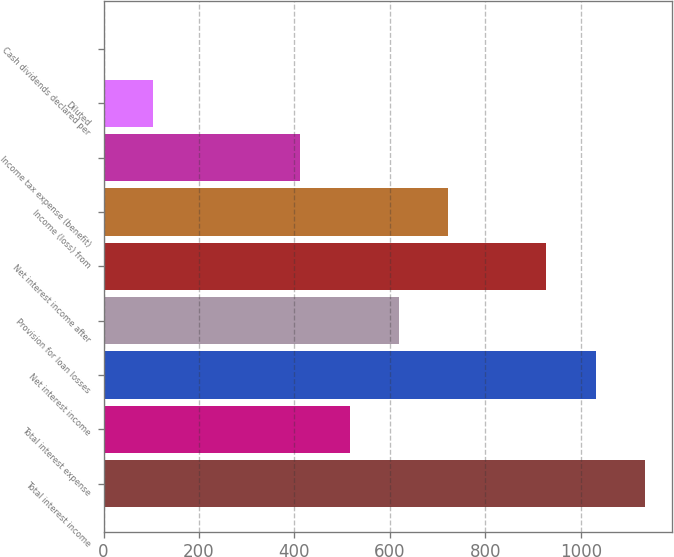<chart> <loc_0><loc_0><loc_500><loc_500><bar_chart><fcel>Total interest income<fcel>Total interest expense<fcel>Net interest income<fcel>Provision for loan losses<fcel>Net interest income after<fcel>Income (loss) from<fcel>Income tax expense (benefit)<fcel>Diluted<fcel>Cash dividends declared per<nl><fcel>1134.11<fcel>515.51<fcel>1031.01<fcel>618.61<fcel>927.91<fcel>721.71<fcel>412.41<fcel>103.11<fcel>0.01<nl></chart> 